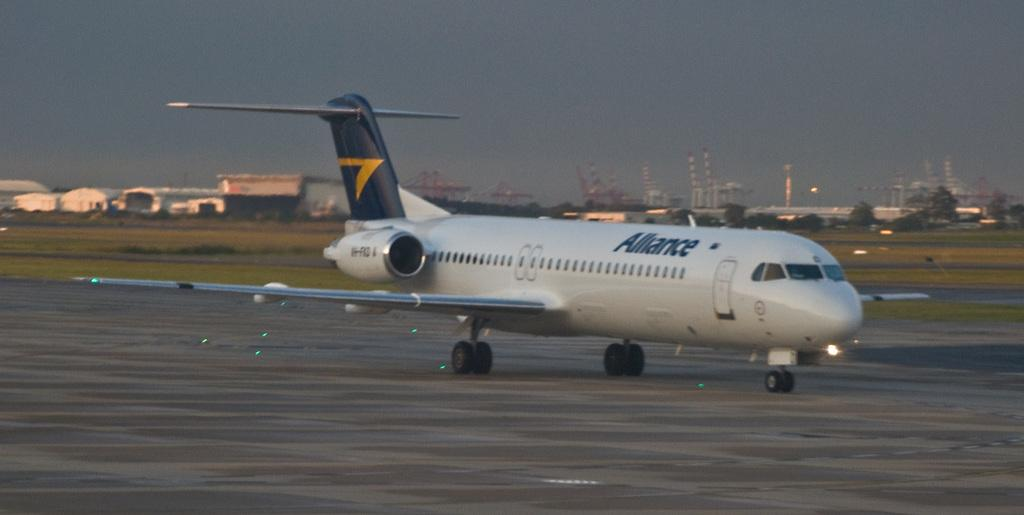<image>
Describe the image concisely. a plane with the word 'alliance' on the side of it 